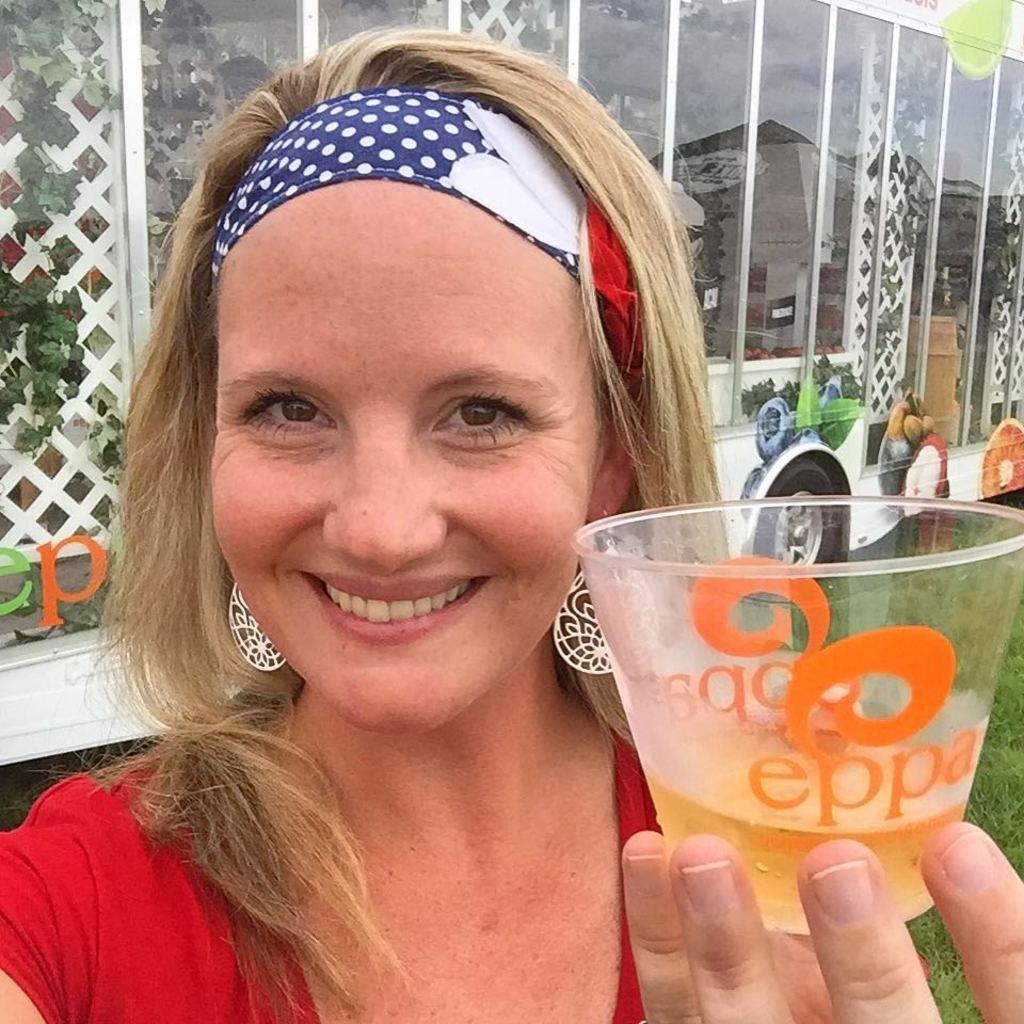Please provide a concise description of this image. In this picture I can see a woman in front and I see that she is holding a glass and I can also see that, she is smiling. In the background I can see the grass and I can see the plants through the glasses. 